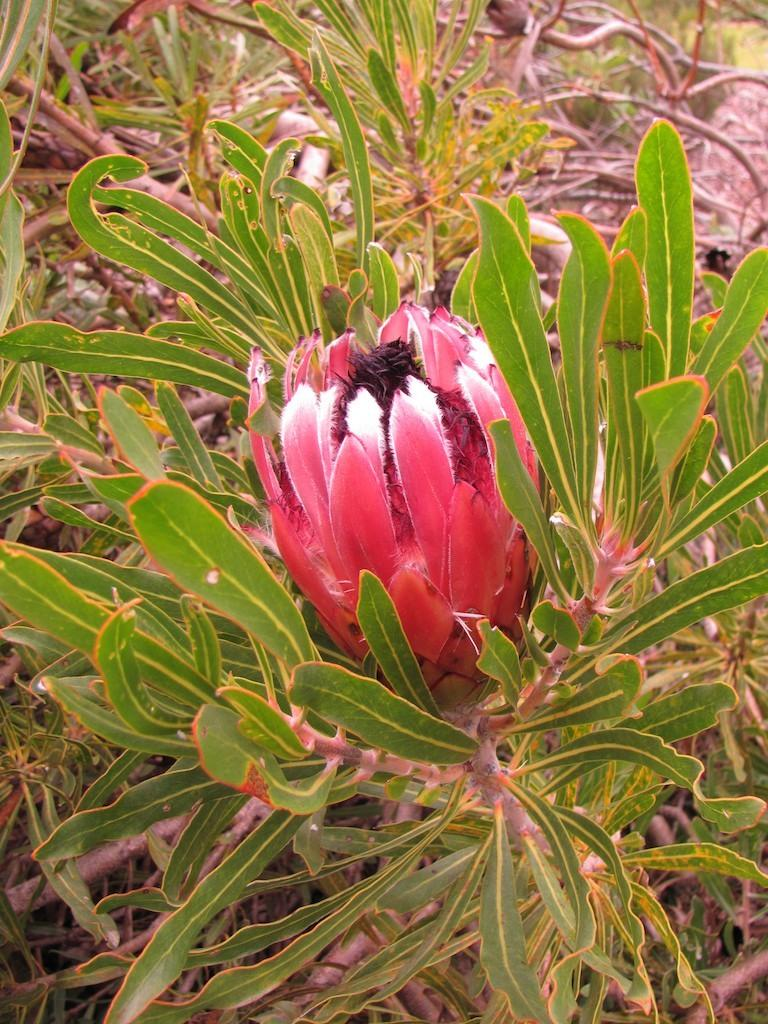What type of living organisms can be seen in the image? Plants can be seen in the image. Can you identify any specific type of plant in the image? Yes, there is a flower in the image. What type of horn can be seen on the flower in the image? There is no horn present on the flower in the image. Can you tell me how many brothers the flower has in the image? The image does not depict any brothers or relationships between the plants or flowers. 